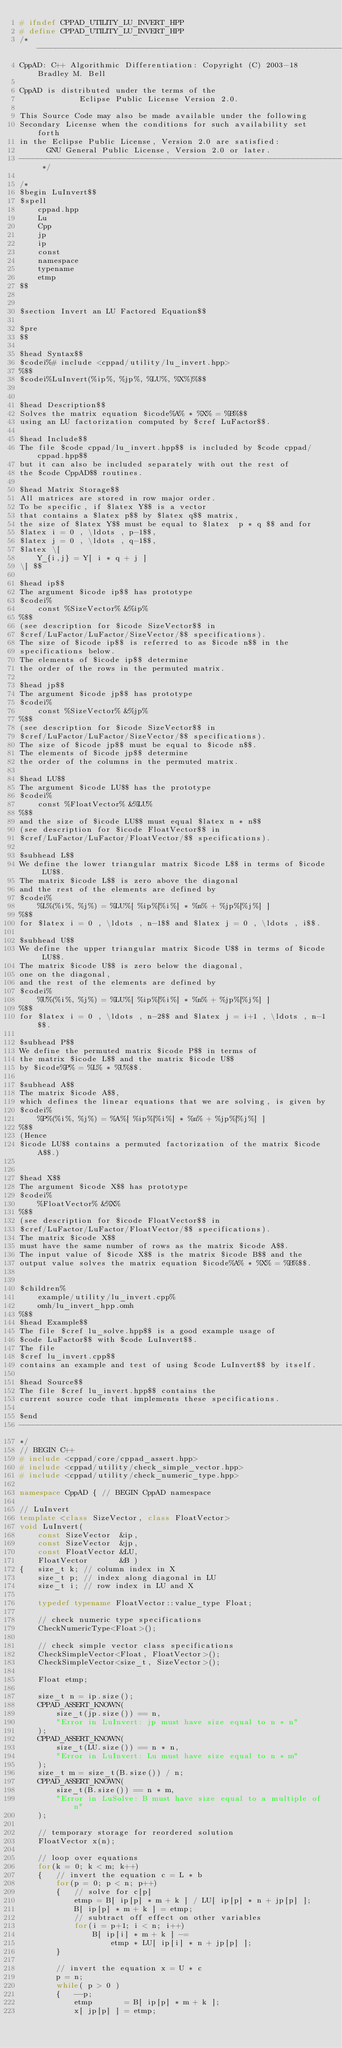<code> <loc_0><loc_0><loc_500><loc_500><_C++_># ifndef CPPAD_UTILITY_LU_INVERT_HPP
# define CPPAD_UTILITY_LU_INVERT_HPP
/* --------------------------------------------------------------------------
CppAD: C++ Algorithmic Differentiation: Copyright (C) 2003-18 Bradley M. Bell

CppAD is distributed under the terms of the
             Eclipse Public License Version 2.0.

This Source Code may also be made available under the following
Secondary License when the conditions for such availability set forth
in the Eclipse Public License, Version 2.0 are satisfied:
      GNU General Public License, Version 2.0 or later.
---------------------------------------------------------------------------- */

/*
$begin LuInvert$$
$spell
    cppad.hpp
    Lu
    Cpp
    jp
    ip
    const
    namespace
    typename
    etmp
$$


$section Invert an LU Factored Equation$$

$pre
$$

$head Syntax$$
$codei%# include <cppad/utility/lu_invert.hpp>
%$$
$codei%LuInvert(%ip%, %jp%, %LU%, %X%)%$$


$head Description$$
Solves the matrix equation $icode%A% * %X% = %B%$$
using an LU factorization computed by $cref LuFactor$$.

$head Include$$
The file $code cppad/lu_invert.hpp$$ is included by $code cppad/cppad.hpp$$
but it can also be included separately with out the rest of
the $code CppAD$$ routines.

$head Matrix Storage$$
All matrices are stored in row major order.
To be specific, if $latex Y$$ is a vector
that contains a $latex p$$ by $latex q$$ matrix,
the size of $latex Y$$ must be equal to $latex  p * q $$ and for
$latex i = 0 , \ldots , p-1$$,
$latex j = 0 , \ldots , q-1$$,
$latex \[
    Y_{i,j} = Y[ i * q + j ]
\] $$

$head ip$$
The argument $icode ip$$ has prototype
$codei%
    const %SizeVector% &%ip%
%$$
(see description for $icode SizeVector$$ in
$cref/LuFactor/LuFactor/SizeVector/$$ specifications).
The size of $icode ip$$ is referred to as $icode n$$ in the
specifications below.
The elements of $icode ip$$ determine
the order of the rows in the permuted matrix.

$head jp$$
The argument $icode jp$$ has prototype
$codei%
    const %SizeVector% &%jp%
%$$
(see description for $icode SizeVector$$ in
$cref/LuFactor/LuFactor/SizeVector/$$ specifications).
The size of $icode jp$$ must be equal to $icode n$$.
The elements of $icode jp$$ determine
the order of the columns in the permuted matrix.

$head LU$$
The argument $icode LU$$ has the prototype
$codei%
    const %FloatVector% &%LU%
%$$
and the size of $icode LU$$ must equal $latex n * n$$
(see description for $icode FloatVector$$ in
$cref/LuFactor/LuFactor/FloatVector/$$ specifications).

$subhead L$$
We define the lower triangular matrix $icode L$$ in terms of $icode LU$$.
The matrix $icode L$$ is zero above the diagonal
and the rest of the elements are defined by
$codei%
    %L%(%i%, %j%) = %LU%[ %ip%[%i%] * %n% + %jp%[%j%] ]
%$$
for $latex i = 0 , \ldots , n-1$$ and $latex j = 0 , \ldots , i$$.

$subhead U$$
We define the upper triangular matrix $icode U$$ in terms of $icode LU$$.
The matrix $icode U$$ is zero below the diagonal,
one on the diagonal,
and the rest of the elements are defined by
$codei%
    %U%(%i%, %j%) = %LU%[ %ip%[%i%] * %n% + %jp%[%j%] ]
%$$
for $latex i = 0 , \ldots , n-2$$ and $latex j = i+1 , \ldots , n-1$$.

$subhead P$$
We define the permuted matrix $icode P$$ in terms of
the matrix $icode L$$ and the matrix $icode U$$
by $icode%P% = %L% * %U%$$.

$subhead A$$
The matrix $icode A$$,
which defines the linear equations that we are solving, is given by
$codei%
    %P%(%i%, %j%) = %A%[ %ip%[%i%] * %n% + %jp%[%j%] ]
%$$
(Hence
$icode LU$$ contains a permuted factorization of the matrix $icode A$$.)


$head X$$
The argument $icode X$$ has prototype
$codei%
    %FloatVector% &%X%
%$$
(see description for $icode FloatVector$$ in
$cref/LuFactor/LuFactor/FloatVector/$$ specifications).
The matrix $icode X$$
must have the same number of rows as the matrix $icode A$$.
The input value of $icode X$$ is the matrix $icode B$$ and the
output value solves the matrix equation $icode%A% * %X% = %B%$$.


$children%
    example/utility/lu_invert.cpp%
    omh/lu_invert_hpp.omh
%$$
$head Example$$
The file $cref lu_solve.hpp$$ is a good example usage of
$code LuFactor$$ with $code LuInvert$$.
The file
$cref lu_invert.cpp$$
contains an example and test of using $code LuInvert$$ by itself.

$head Source$$
The file $cref lu_invert.hpp$$ contains the
current source code that implements these specifications.

$end
--------------------------------------------------------------------------
*/
// BEGIN C++
# include <cppad/core/cppad_assert.hpp>
# include <cppad/utility/check_simple_vector.hpp>
# include <cppad/utility/check_numeric_type.hpp>

namespace CppAD { // BEGIN CppAD namespace

// LuInvert
template <class SizeVector, class FloatVector>
void LuInvert(
    const SizeVector  &ip,
    const SizeVector  &jp,
    const FloatVector &LU,
    FloatVector       &B )
{   size_t k; // column index in X
    size_t p; // index along diagonal in LU
    size_t i; // row index in LU and X

    typedef typename FloatVector::value_type Float;

    // check numeric type specifications
    CheckNumericType<Float>();

    // check simple vector class specifications
    CheckSimpleVector<Float, FloatVector>();
    CheckSimpleVector<size_t, SizeVector>();

    Float etmp;

    size_t n = ip.size();
    CPPAD_ASSERT_KNOWN(
        size_t(jp.size()) == n,
        "Error in LuInvert: jp must have size equal to n * n"
    );
    CPPAD_ASSERT_KNOWN(
        size_t(LU.size()) == n * n,
        "Error in LuInvert: Lu must have size equal to n * m"
    );
    size_t m = size_t(B.size()) / n;
    CPPAD_ASSERT_KNOWN(
        size_t(B.size()) == n * m,
        "Error in LuSolve: B must have size equal to a multiple of n"
    );

    // temporary storage for reordered solution
    FloatVector x(n);

    // loop over equations
    for(k = 0; k < m; k++)
    {   // invert the equation c = L * b
        for(p = 0; p < n; p++)
        {   // solve for c[p]
            etmp = B[ ip[p] * m + k ] / LU[ ip[p] * n + jp[p] ];
            B[ ip[p] * m + k ] = etmp;
            // subtract off effect on other variables
            for(i = p+1; i < n; i++)
                B[ ip[i] * m + k ] -=
                    etmp * LU[ ip[i] * n + jp[p] ];
        }

        // invert the equation x = U * c
        p = n;
        while( p > 0 )
        {   --p;
            etmp       = B[ ip[p] * m + k ];
            x[ jp[p] ] = etmp;</code> 